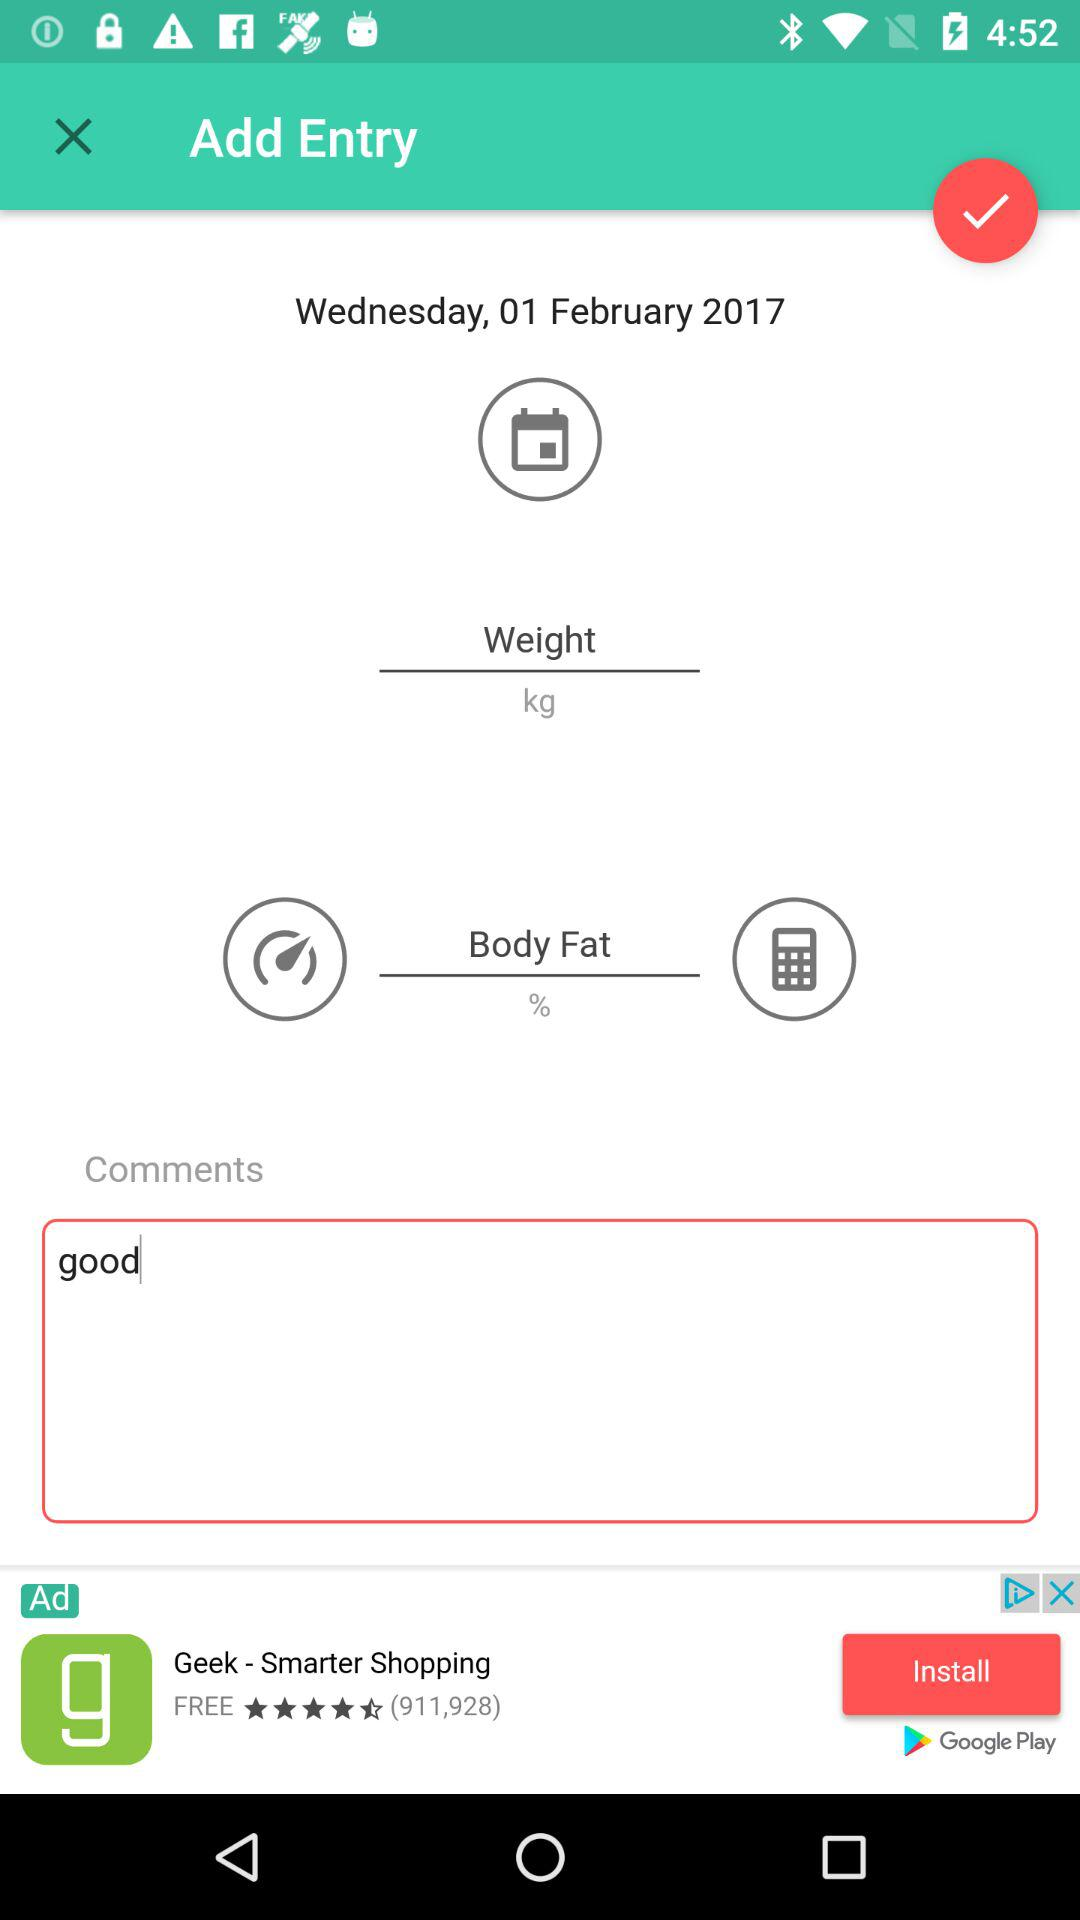What was the day on 1st February 2017? The day was Wednesday. 